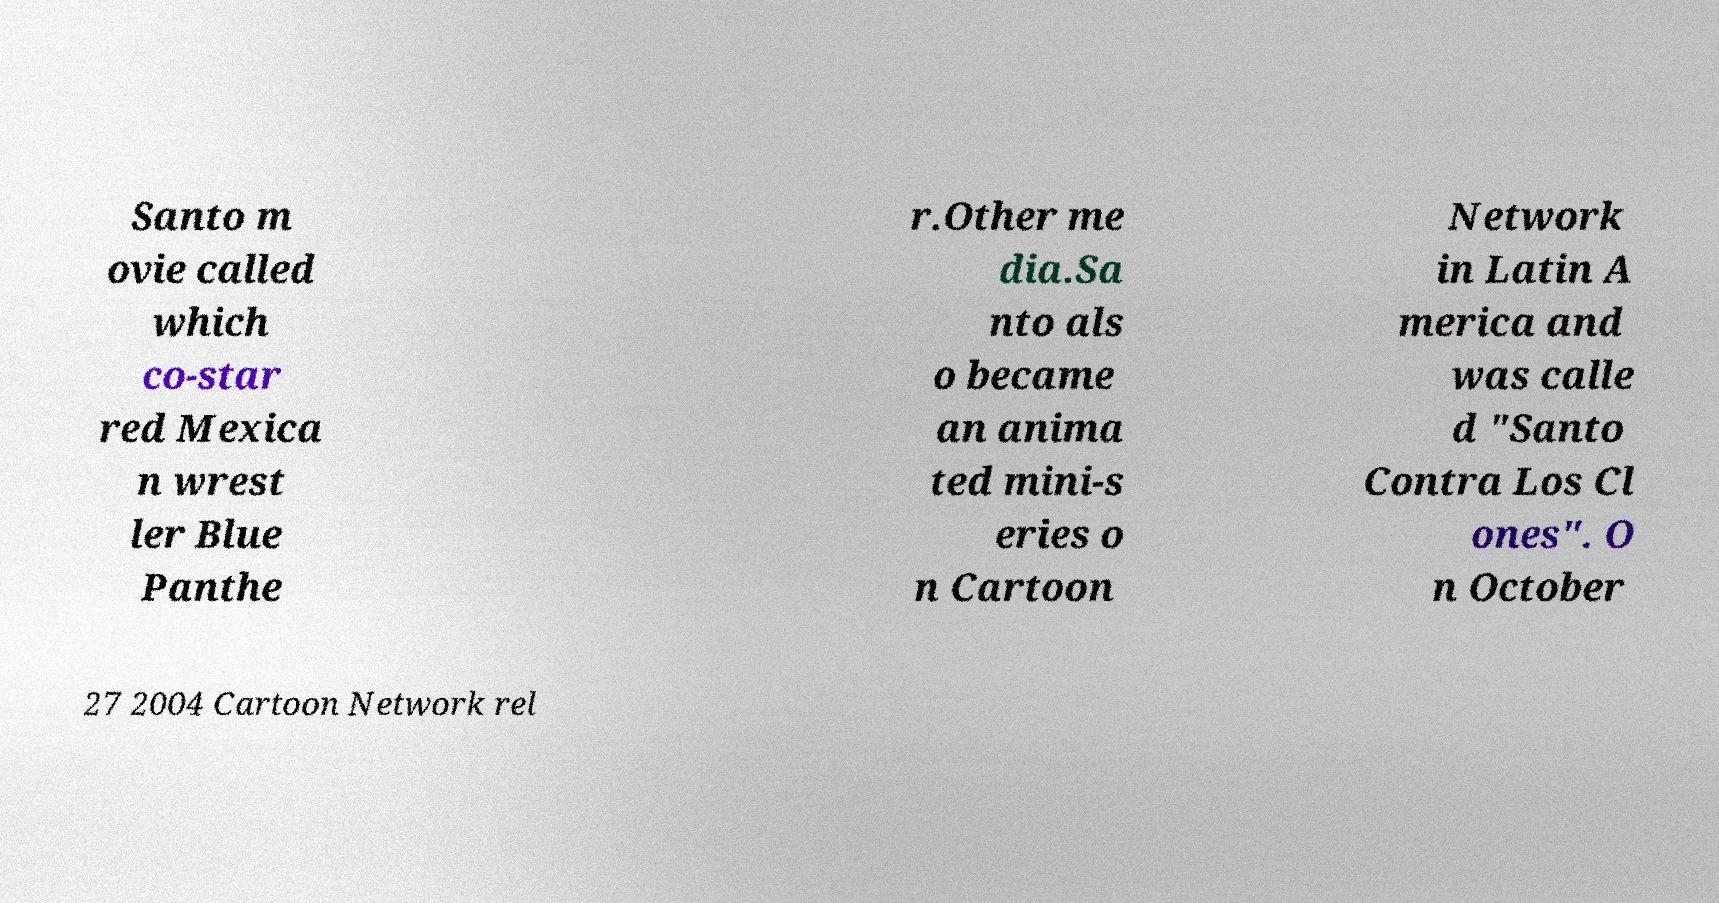I need the written content from this picture converted into text. Can you do that? Santo m ovie called which co-star red Mexica n wrest ler Blue Panthe r.Other me dia.Sa nto als o became an anima ted mini-s eries o n Cartoon Network in Latin A merica and was calle d "Santo Contra Los Cl ones". O n October 27 2004 Cartoon Network rel 